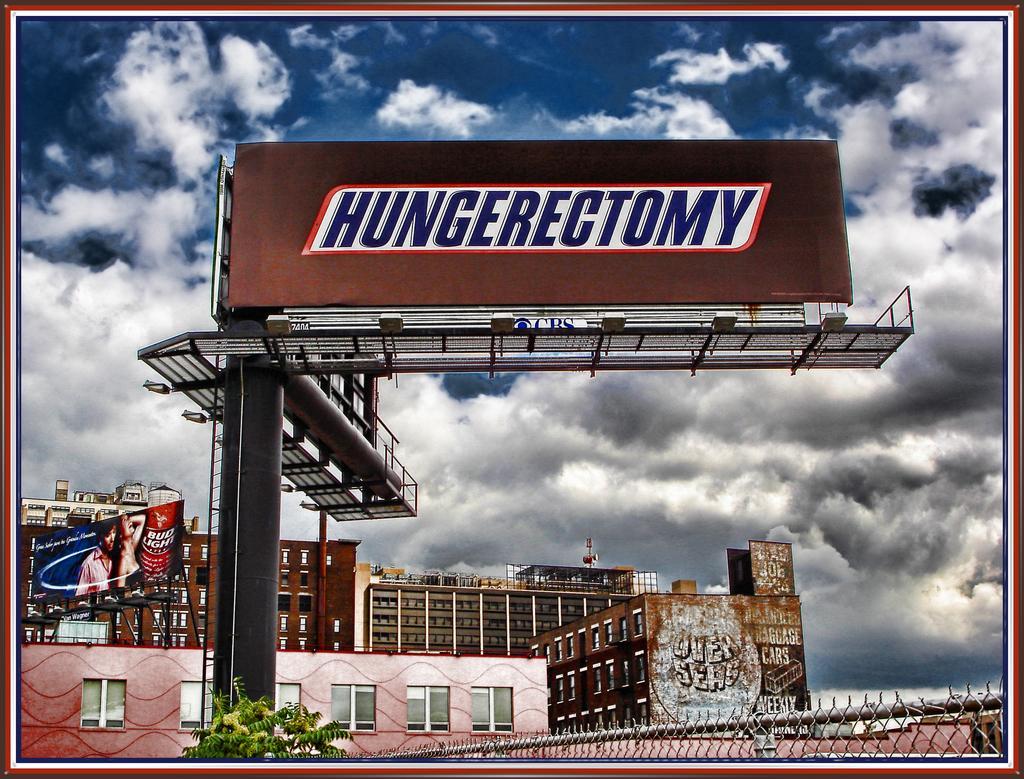Could you give a brief overview of what you see in this image? This image consists of a stand along with the hoarding. In the background, there are buildings along with windows. At the bottom, there is a fencing. It looks like an edited image. At the top, there are clouds in the sky. 